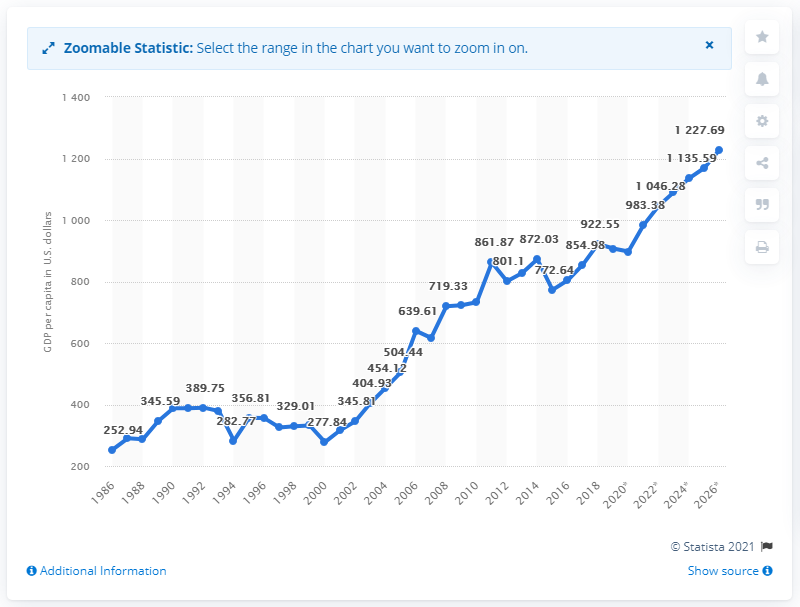Specify some key components in this picture. In 2020, the Gross Domestic Product (GDP) per capita in Mali was 897.29 US dollars. 